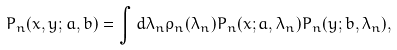<formula> <loc_0><loc_0><loc_500><loc_500>P _ { n } ( x , y ; a , b ) = \int d \lambda _ { n } \rho _ { n } ( \lambda _ { n } ) P _ { n } ( x ; a , \lambda _ { n } ) P _ { n } ( y ; b , \lambda _ { n } ) ,</formula> 